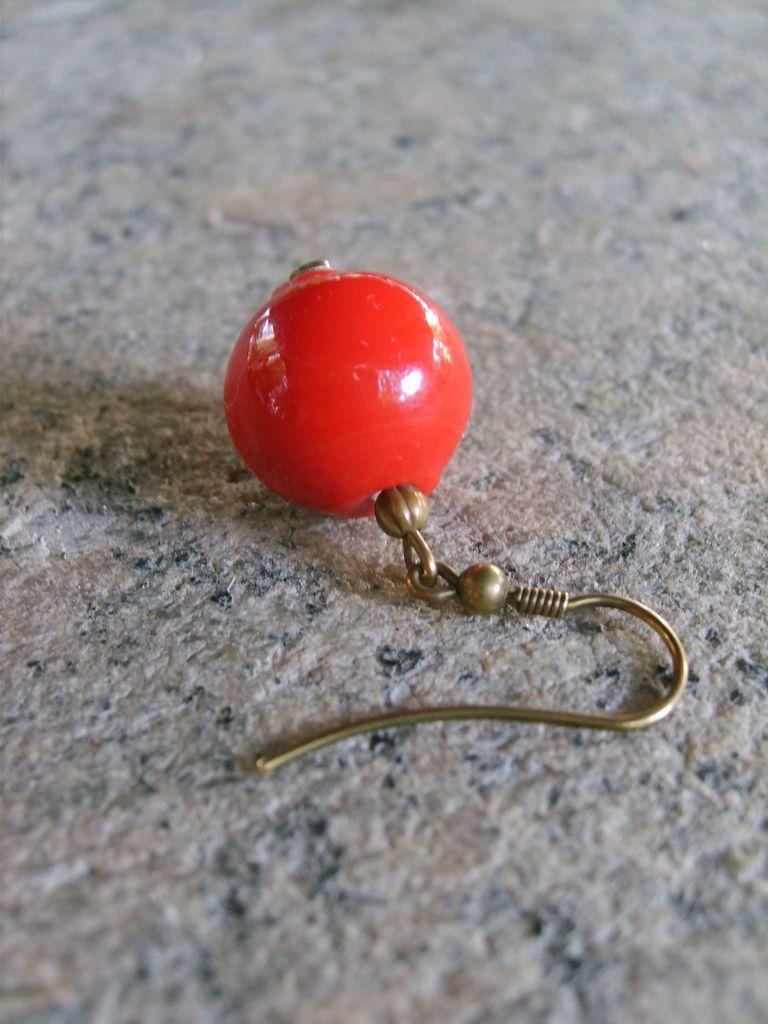Can you describe this image briefly? In this image we can see there is an earring placed on the floor. 